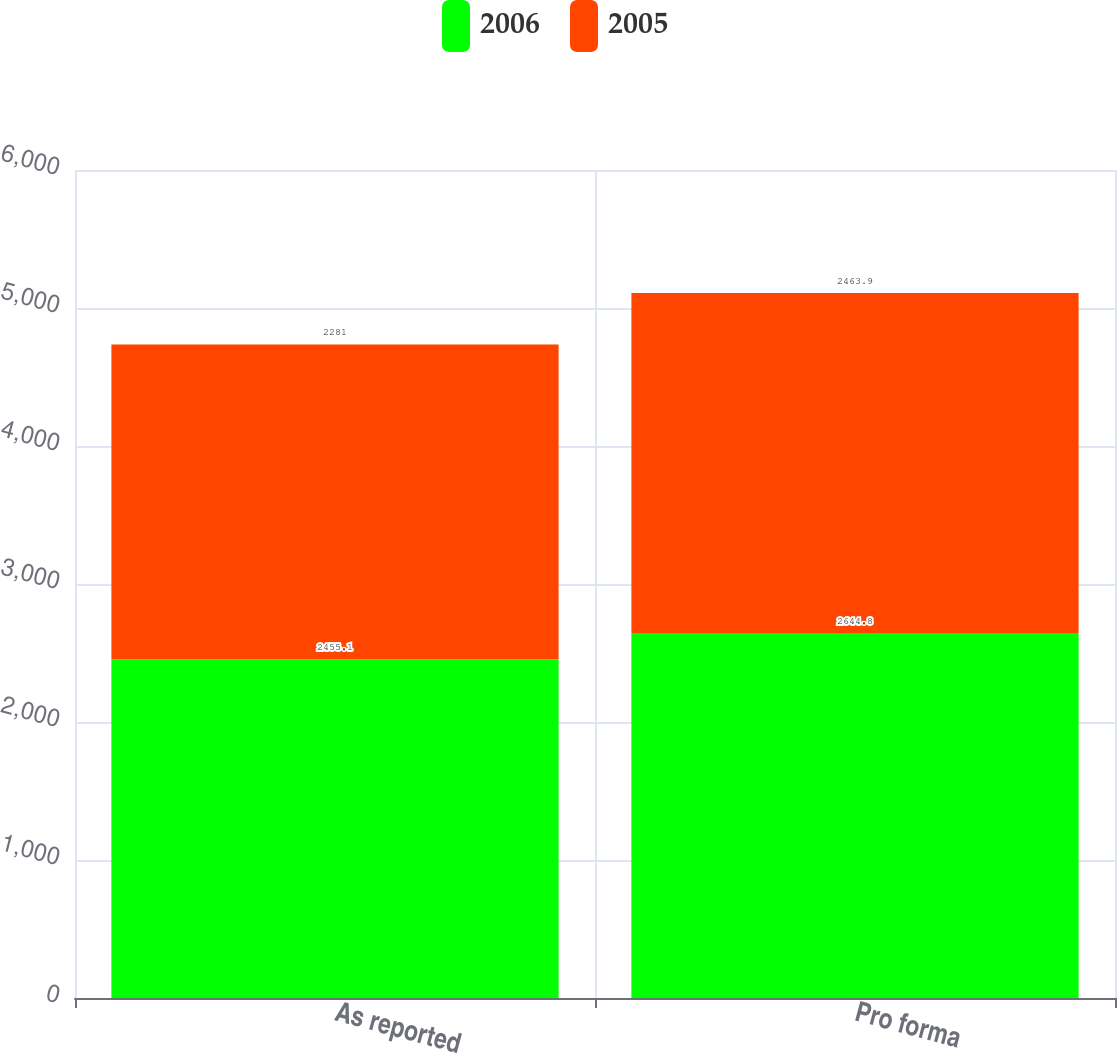<chart> <loc_0><loc_0><loc_500><loc_500><stacked_bar_chart><ecel><fcel>As reported<fcel>Pro forma<nl><fcel>2006<fcel>2455.1<fcel>2644.8<nl><fcel>2005<fcel>2281<fcel>2463.9<nl></chart> 